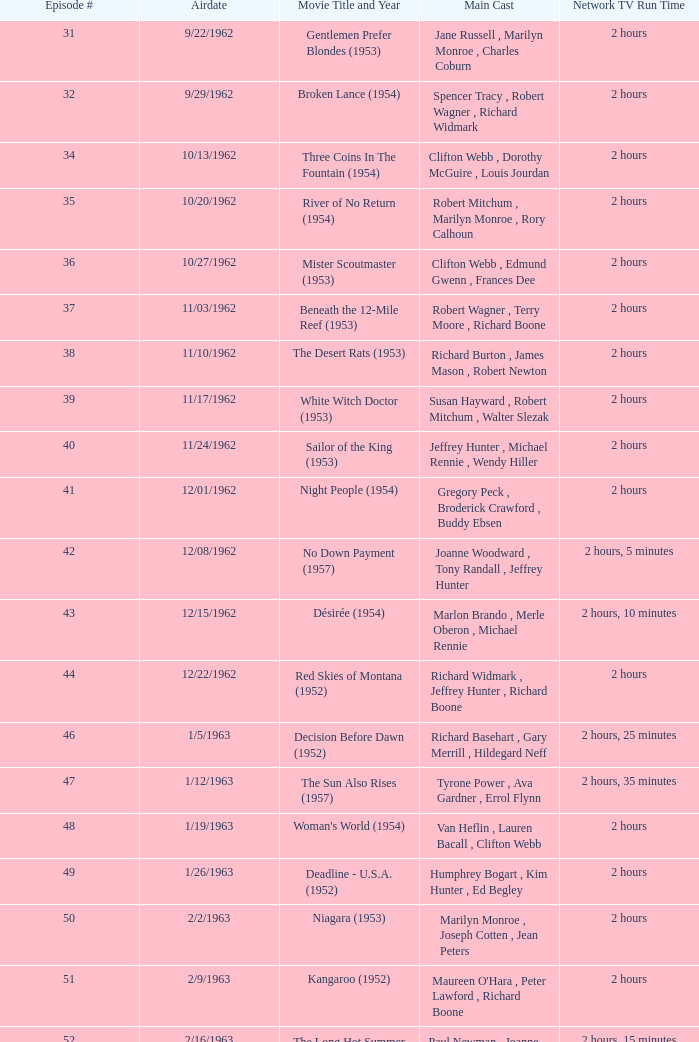Who was the cast on the 3/23/1963 episode? Dana Wynter , Mel Ferrer , Theodore Bikel. 